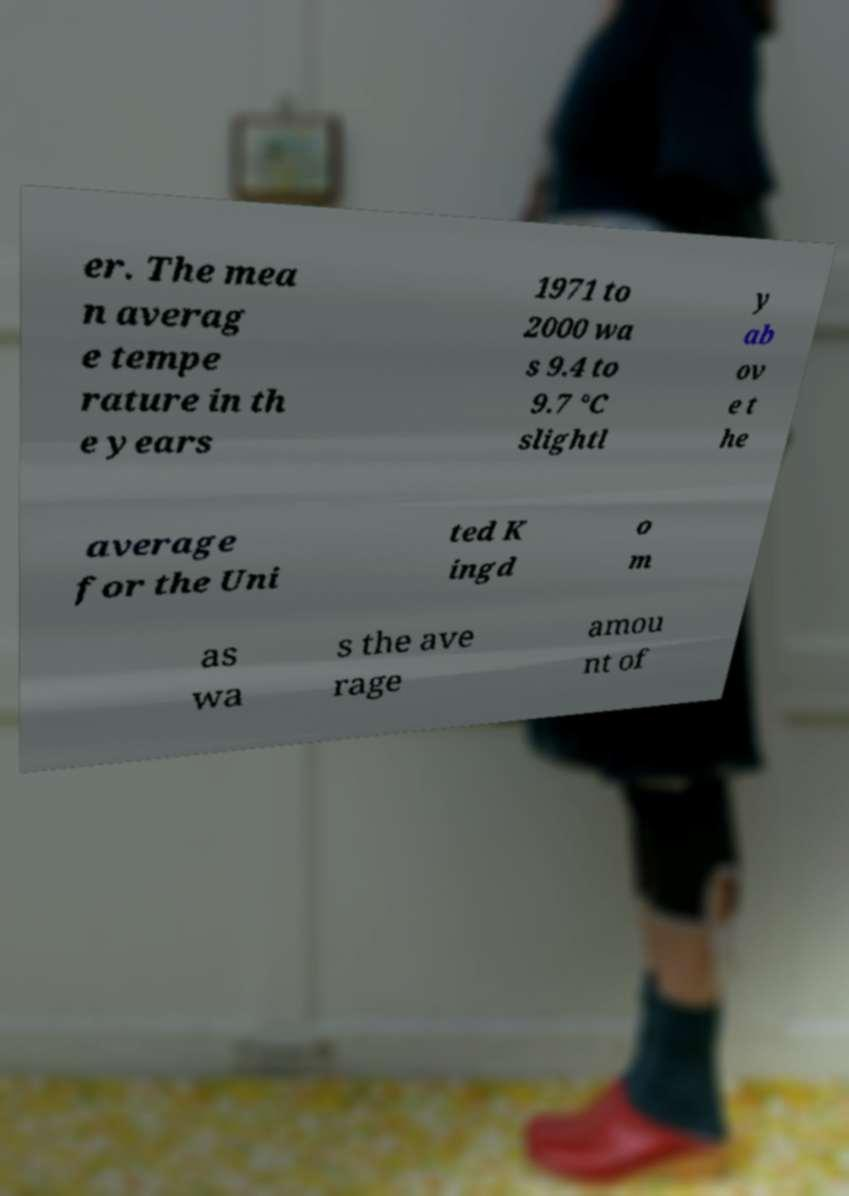Can you accurately transcribe the text from the provided image for me? er. The mea n averag e tempe rature in th e years 1971 to 2000 wa s 9.4 to 9.7 °C slightl y ab ov e t he average for the Uni ted K ingd o m as wa s the ave rage amou nt of 